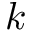Convert formula to latex. <formula><loc_0><loc_0><loc_500><loc_500>k</formula> 